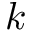Convert formula to latex. <formula><loc_0><loc_0><loc_500><loc_500>k</formula> 